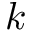Convert formula to latex. <formula><loc_0><loc_0><loc_500><loc_500>k</formula> 